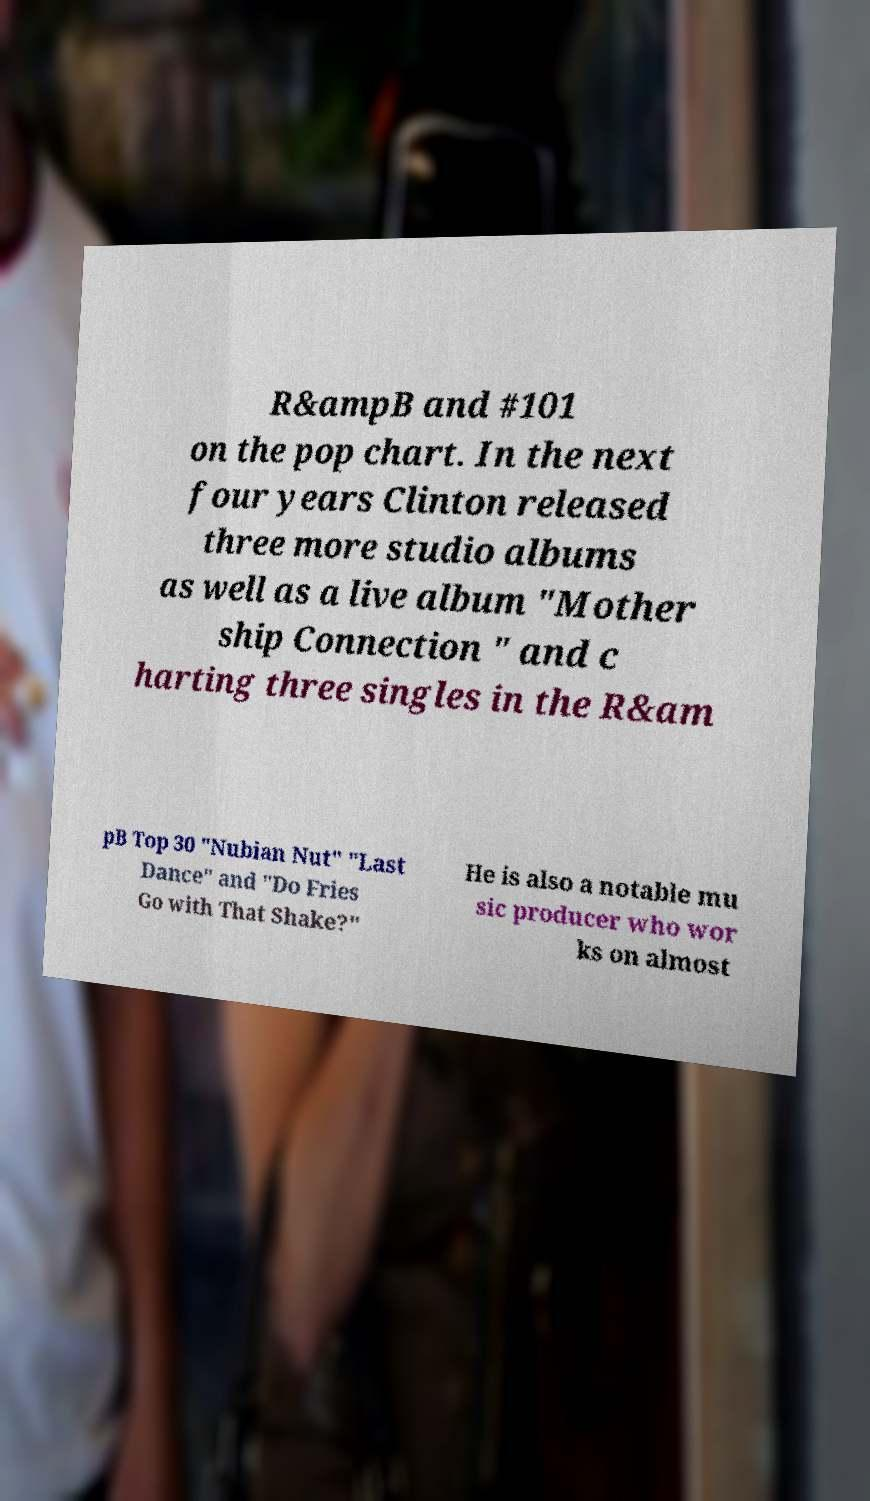Could you extract and type out the text from this image? R&ampB and #101 on the pop chart. In the next four years Clinton released three more studio albums as well as a live album "Mother ship Connection " and c harting three singles in the R&am pB Top 30 "Nubian Nut" "Last Dance" and "Do Fries Go with That Shake?" He is also a notable mu sic producer who wor ks on almost 